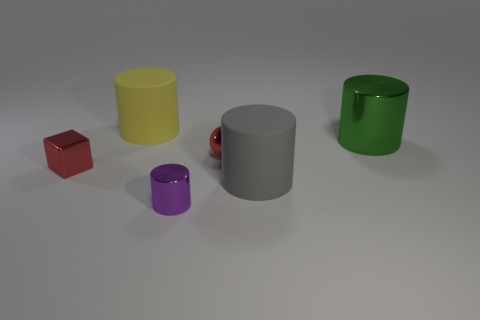Which objects appear to have a smooth surface? The yellow cylinder, the gray cylinder, and the purple cylinder show reflective, smooth surfaces. 